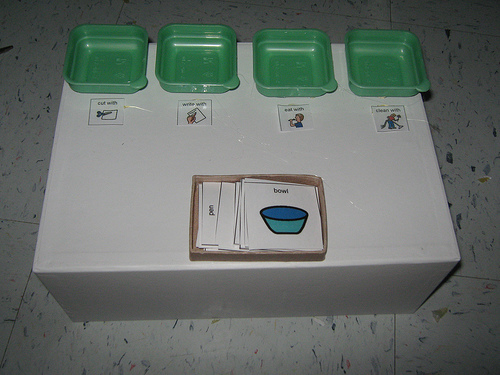<image>
Is there a flash card in the tray? Yes. The flash card is contained within or inside the tray, showing a containment relationship. 